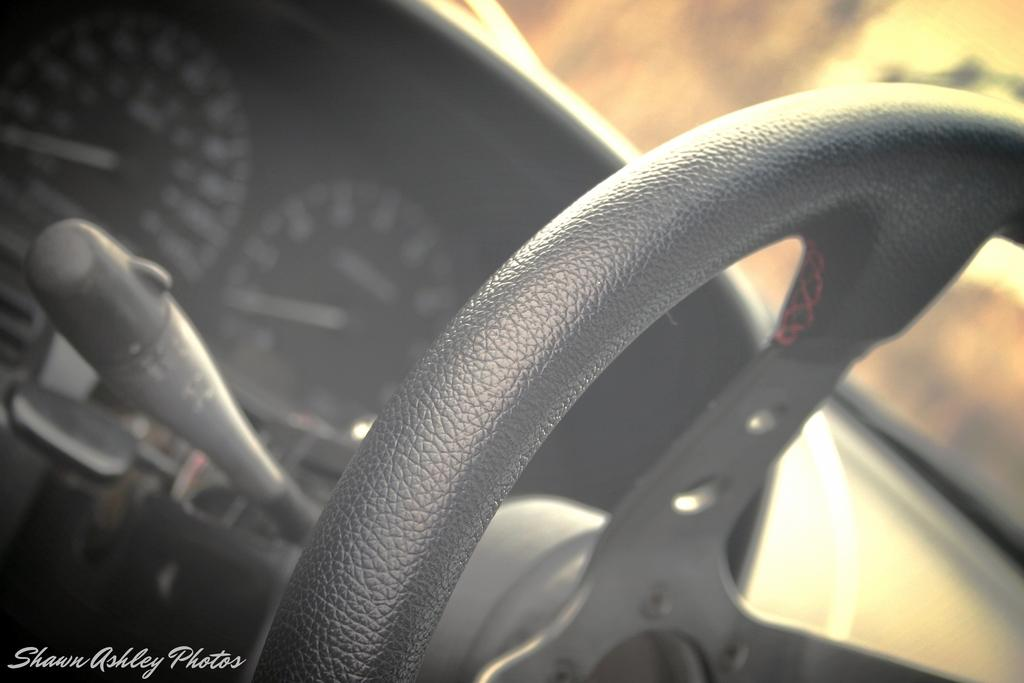What is the main subject of the image? The main subject of the image is a car steering. What color is the car steering? The car steering is in black color. What type of creature can be seen interacting with the car steering in the image? There is no creature present in the image; it only features a car steering. What is the front of the car steering used for in the image? The image only shows the car steering, so it is not possible to determine the function of the front of the steering wheel. 